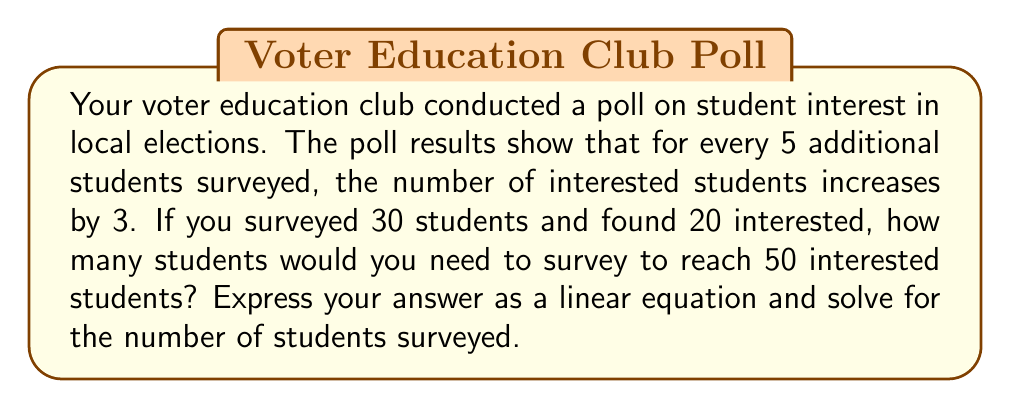Solve this math problem. Let's approach this step-by-step:

1) First, we need to create a linear equation based on the given information:
   Let $x$ be the number of students surveyed and $y$ be the number of interested students.

2) We know that for every 5 additional students surveyed, the number of interested students increases by 3. This gives us the slope of our line: $\frac{3}{5}$

3) We can use the point-slope form of a line: $y - y_1 = m(x - x_1)$
   Where $(x_1, y_1)$ is a known point (30, 20) and $m$ is the slope $\frac{3}{5}$

4) Plugging in these values:
   $y - 20 = \frac{3}{5}(x - 30)$

5) Simplify:
   $y = \frac{3}{5}x - 18 + 20$
   $y = \frac{3}{5}x + 2$

6) Now, we want to find $x$ when $y = 50$:
   $50 = \frac{3}{5}x + 2$

7) Solve for $x$:
   $48 = \frac{3}{5}x$
   $x = 48 \cdot \frac{5}{3} = 80$

Therefore, you would need to survey 80 students to reach 50 interested students.
Answer: 80 students 